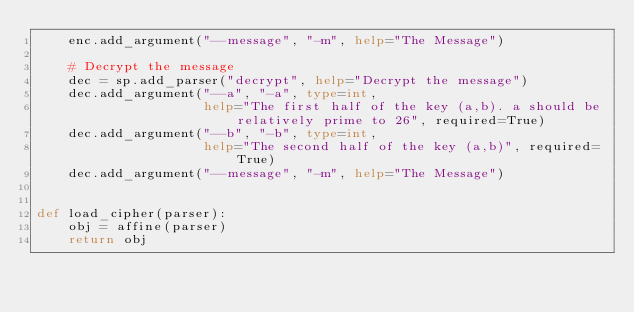<code> <loc_0><loc_0><loc_500><loc_500><_Python_>    enc.add_argument("--message", "-m", help="The Message")

    # Decrypt the message
    dec = sp.add_parser("decrypt", help="Decrypt the message")
    dec.add_argument("--a", "-a", type=int,
                     help="The first half of the key (a,b). a should be relatively prime to 26", required=True)
    dec.add_argument("--b", "-b", type=int,
                     help="The second half of the key (a,b)", required=True)
    dec.add_argument("--message", "-m", help="The Message")


def load_cipher(parser):
    obj = affine(parser)
    return obj
</code> 